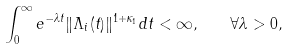Convert formula to latex. <formula><loc_0><loc_0><loc_500><loc_500>\int _ { 0 } ^ { \infty } e ^ { - \lambda t } \| \Lambda _ { i } ( t ) \| ^ { 1 + \kappa _ { 1 } } d t < \infty , \quad \forall \lambda > 0 ,</formula> 